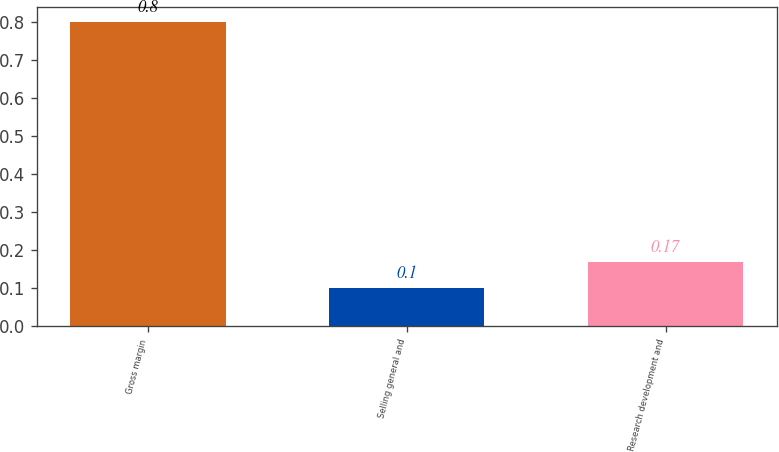Convert chart to OTSL. <chart><loc_0><loc_0><loc_500><loc_500><bar_chart><fcel>Gross margin<fcel>Selling general and<fcel>Research development and<nl><fcel>0.8<fcel>0.1<fcel>0.17<nl></chart> 